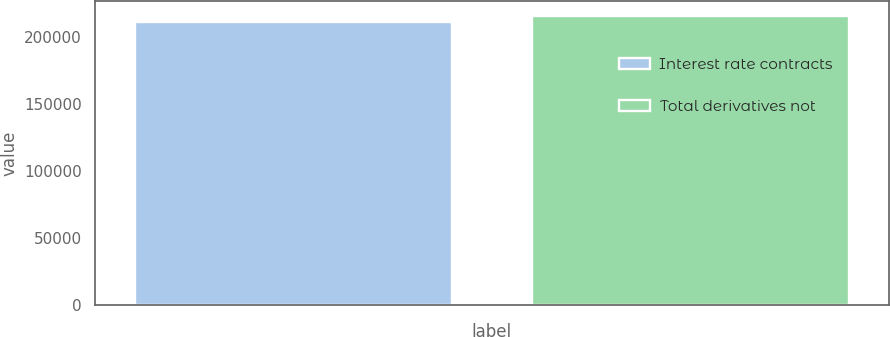Convert chart. <chart><loc_0><loc_0><loc_500><loc_500><bar_chart><fcel>Interest rate contracts<fcel>Total derivatives not<nl><fcel>211552<fcel>216110<nl></chart> 